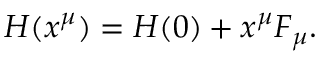Convert formula to latex. <formula><loc_0><loc_0><loc_500><loc_500>H ( x ^ { \mu } ) = H ( 0 ) + x ^ { \mu } F _ { \mu } .</formula> 